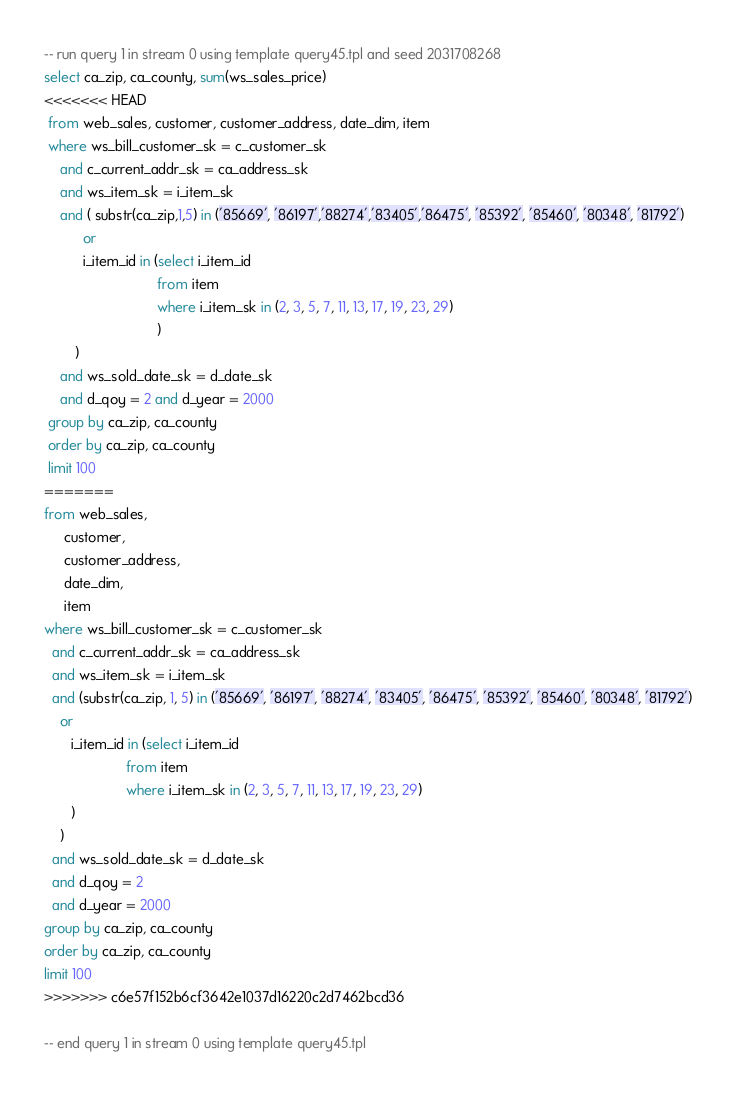Convert code to text. <code><loc_0><loc_0><loc_500><loc_500><_SQL_>-- run query 1 in stream 0 using template query45.tpl and seed 2031708268
select ca_zip, ca_county, sum(ws_sales_price)
<<<<<<< HEAD
 from web_sales, customer, customer_address, date_dim, item
 where ws_bill_customer_sk = c_customer_sk
 	and c_current_addr_sk = ca_address_sk 
 	and ws_item_sk = i_item_sk 
 	and ( substr(ca_zip,1,5) in ('85669', '86197','88274','83405','86475', '85392', '85460', '80348', '81792')
 	      or 
 	      i_item_id in (select i_item_id
                             from item
                             where i_item_sk in (2, 3, 5, 7, 11, 13, 17, 19, 23, 29)
                             )
 	    )
 	and ws_sold_date_sk = d_date_sk
 	and d_qoy = 2 and d_year = 2000
 group by ca_zip, ca_county
 order by ca_zip, ca_county
 limit 100
=======
from web_sales,
     customer,
     customer_address,
     date_dim,
     item
where ws_bill_customer_sk = c_customer_sk
  and c_current_addr_sk = ca_address_sk
  and ws_item_sk = i_item_sk
  and (substr(ca_zip, 1, 5) in ('85669', '86197', '88274', '83405', '86475', '85392', '85460', '80348', '81792')
    or
       i_item_id in (select i_item_id
                     from item
                     where i_item_sk in (2, 3, 5, 7, 11, 13, 17, 19, 23, 29)
       )
    )
  and ws_sold_date_sk = d_date_sk
  and d_qoy = 2
  and d_year = 2000
group by ca_zip, ca_county
order by ca_zip, ca_county
limit 100
>>>>>>> c6e57f152b6cf3642e1037d16220c2d7462bcd36

-- end query 1 in stream 0 using template query45.tpl
</code> 